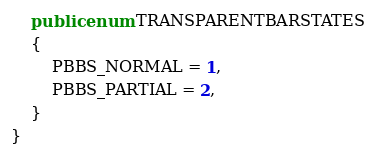Convert code to text. <code><loc_0><loc_0><loc_500><loc_500><_C#_>    public enum TRANSPARENTBARSTATES
    {
        PBBS_NORMAL = 1,
        PBBS_PARTIAL = 2,
    }
}
</code> 